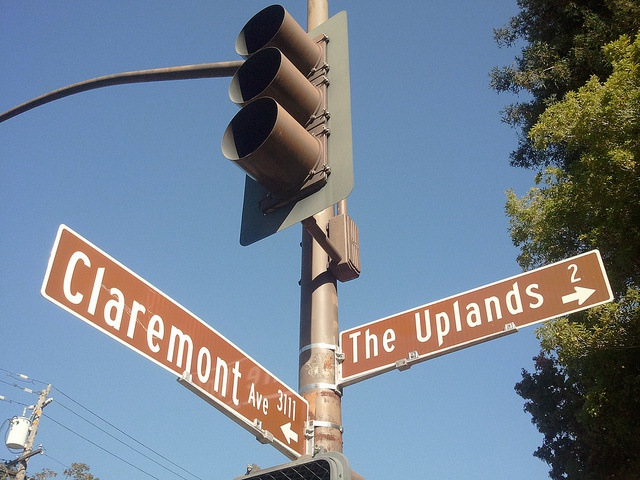Describe the objects in this image and their specific colors. I can see a traffic light in gray, black, and darkgray tones in this image. 